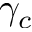<formula> <loc_0><loc_0><loc_500><loc_500>\gamma _ { c }</formula> 